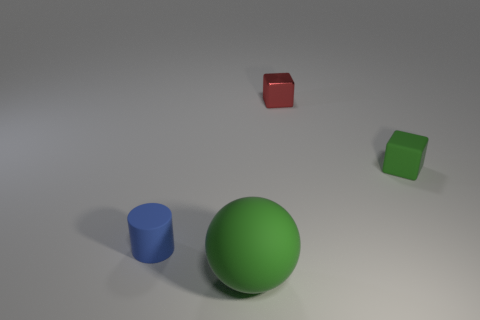Add 3 yellow rubber balls. How many objects exist? 7 Subtract all red blocks. How many blocks are left? 1 Subtract all cylinders. How many objects are left? 3 Add 3 tiny yellow balls. How many tiny yellow balls exist? 3 Subtract 0 blue spheres. How many objects are left? 4 Subtract all brown cylinders. Subtract all purple blocks. How many cylinders are left? 1 Subtract all small matte cylinders. Subtract all tiny rubber cubes. How many objects are left? 2 Add 3 metal blocks. How many metal blocks are left? 4 